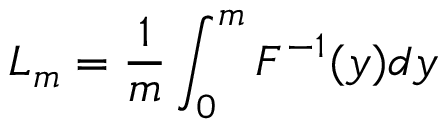Convert formula to latex. <formula><loc_0><loc_0><loc_500><loc_500>L _ { m } = \frac { 1 } { m } \int _ { 0 } ^ { m } F ^ { - 1 } ( y ) d y</formula> 